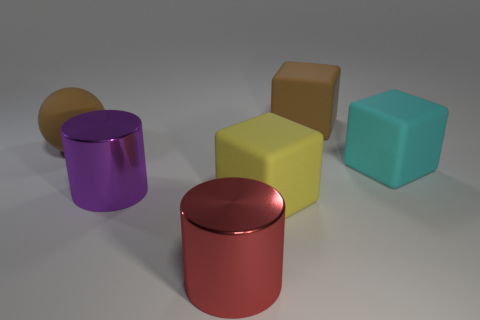What number of other things are the same shape as the yellow thing?
Offer a very short reply. 2. What number of blue things are either rubber blocks or small blocks?
Ensure brevity in your answer.  0. Do the cyan thing and the large red metallic thing have the same shape?
Your answer should be very brief. No. Is there a cyan cube behind the brown rubber block that is right of the brown sphere?
Give a very brief answer. No. Are there the same number of big yellow rubber objects behind the large cyan object and brown matte objects?
Provide a short and direct response. No. What number of other objects are the same size as the yellow matte thing?
Your answer should be very brief. 5. Does the big cylinder that is behind the yellow cube have the same material as the big brown thing left of the red metal cylinder?
Give a very brief answer. No. How big is the block that is behind the brown thing on the left side of the big red thing?
Make the answer very short. Large. Is there a large metal object of the same color as the matte ball?
Your response must be concise. No. There is a big cylinder that is on the left side of the red metal cylinder; is it the same color as the matte object in front of the large purple cylinder?
Your answer should be very brief. No. 